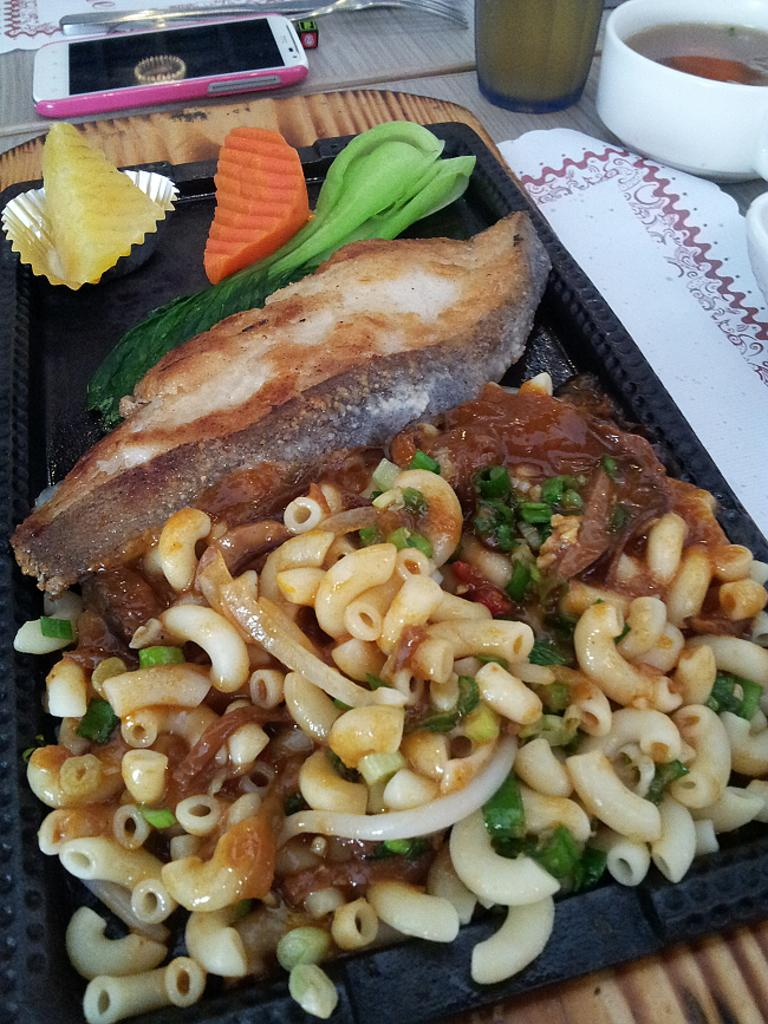What is the main piece of furniture in the image? There is a table in the image. What is placed on the table? On the table, there is a tray with some food items, a bowl, a spoon, a cell phone, a glass, and a drink. Can you describe the utensil on the table? There is a spoon on the table. What is the purpose of the glass on the table? The glass on the table is likely for holding the drink. What other objects can be seen on the table? There are a few other objects on the table. What type of noise can be heard coming from the books in the image? There are no books present in the image, so it is not possible to determine what, if any, noise might be heard. 